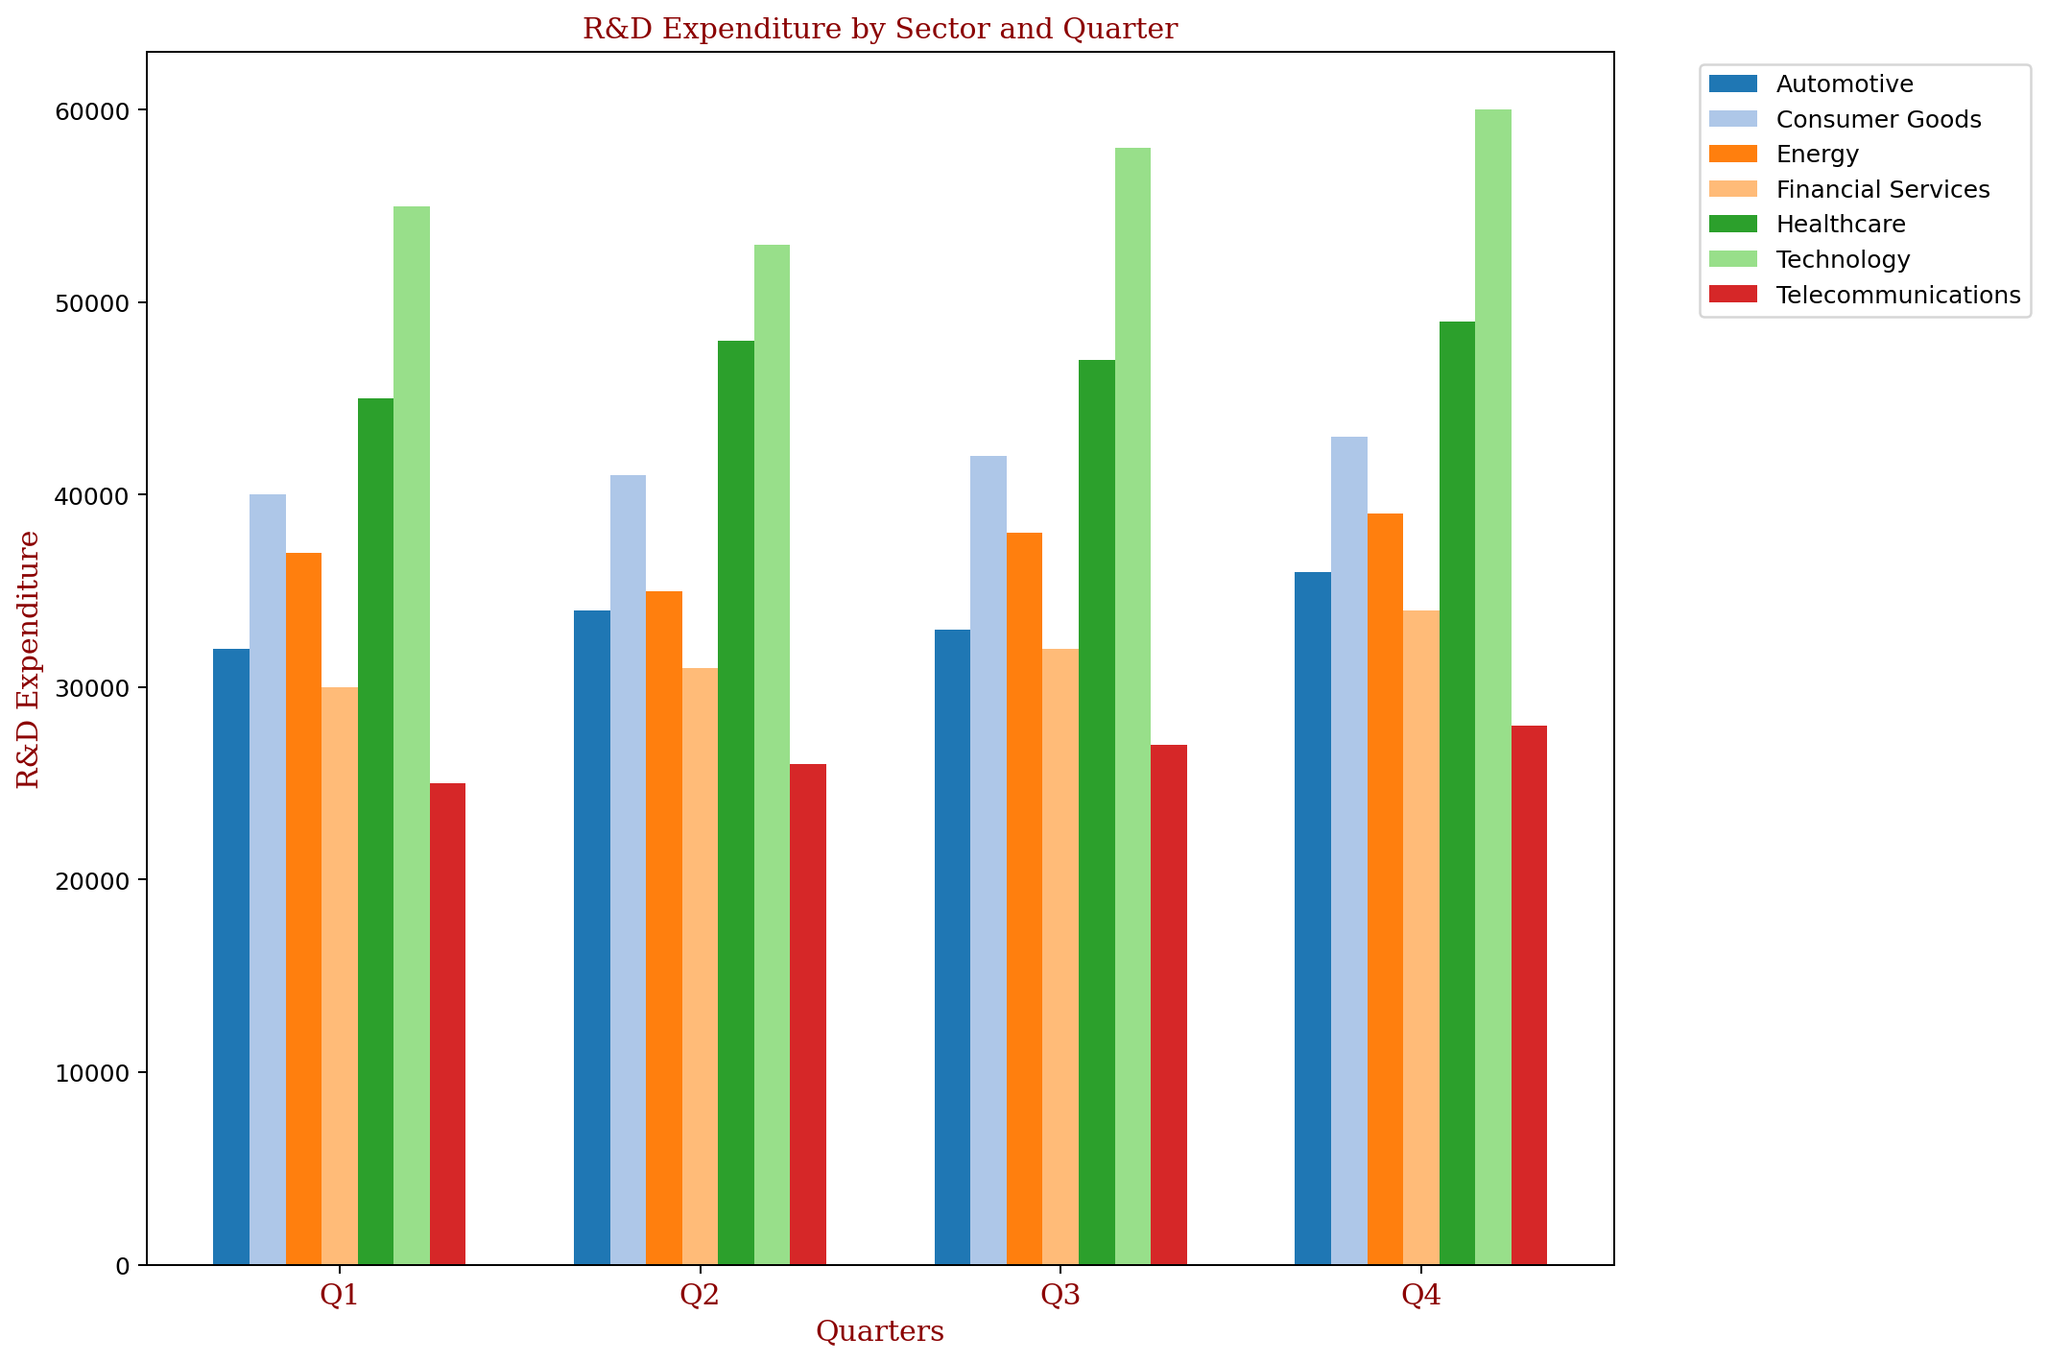Which sector shows the highest R&D expenditure for Q4? To answer this, compare the heights of the Q4 bars for all sectors. The highest bar in Q4 corresponds to the Technology sector, which has the highest R&D expenditure.
Answer: Technology Which quarter had the lowest R&D expenditure in the Automotive sector? Compare the heights of the bars for the Automotive sector across all quarters. The shortest bar is in Q1.
Answer: Q1 How does the R&D expenditure of Consumer Goods in Q2 compare to Q4? Compare the heights of the bars for Consumer Goods in Q2 and Q4. The Q4 bar is slightly higher than the Q2 bar.
Answer: Q2 has lower expenditure than Q4 What is the total R&D expenditure for the Technology sector across all quarters? Sum the R&D expenditures for Technology in all quarters: 55000 (Q1) + 53000 (Q2) + 58000 (Q3) + 60000 (Q4) = 226000
Answer: 226000 Which sector has the most consistent R&D expenditure across all quarters? Compare the consistency (similar height) of the bars for each sector. Telecommunications sector has the most consistent R&D expenditures as the bar height differences are minimal.
Answer: Telecommunications What is the average R&D expenditure per quarter for the Energy sector? Sum the R&D expenditures for Energy and divide by 4: (37000 + 35000 + 38000 + 39000) / 4 = 37250
Answer: 37250 Which sector has the largest increase in R&D expenditure from Q1 to Q4? Calculate the difference between R&D expenditures of Q4 and Q1 for each sector, and compare them: Technology: 60000 - 55000 = 5000, Healthcare: 49000 - 45000 = 4000, Automotive: 36000 - 32000 = 4000, Energy: 39000 - 37000 = 2000, Telecommunications: 28000 - 25000 = 3000, Consumer Goods: 43000 - 40000 = 3000, Financial Services: 34000 - 30000 = 4000. The Technology sector has the largest increase.
Answer: Technology Which two sectors have the closest R&D expenditure in Q3? Compare the heights of the Q3 bars across all sectors, and identify the closest in value. The Healthcare sector (47000) and Consumer Goods sector (42000) are the closest.
Answer: Healthcare and Consumer Goods In which quarter do all sectors have their highest R&D expenditure on average? Calculate the average R&D expenditure for each quarter: Q1: (55000+45000+32000+37000+25000+40000+30000)/7 = 37,429, Q2: (53000+48000+34000+35000+26000+41000+31000)/7 = 37,714, Q3: (58000+47000+33000+38000+27000+42000+32000)/7 = 38,143, Q4: (60000+49000+36000+39000+28000+43000+34000)/7 = 39,000. Q4 has the highest average at 39,000.
Answer: Q4 Which sector has the steepest decline in R&D expenditure in any quarter? Examine each sector's quarterly R&D expenditures for the greatest single drop. The Energy sector from Q1 to Q2 declines from 37,000 to 35,000.
Answer: Energy 